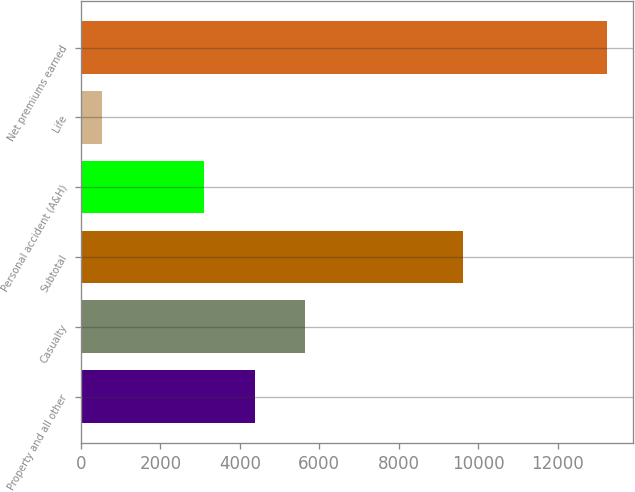Convert chart to OTSL. <chart><loc_0><loc_0><loc_500><loc_500><bar_chart><fcel>Property and all other<fcel>Casualty<fcel>Subtotal<fcel>Personal accident (A&H)<fcel>Life<fcel>Net premiums earned<nl><fcel>4374.3<fcel>5645.6<fcel>9610<fcel>3103<fcel>527<fcel>13240<nl></chart> 